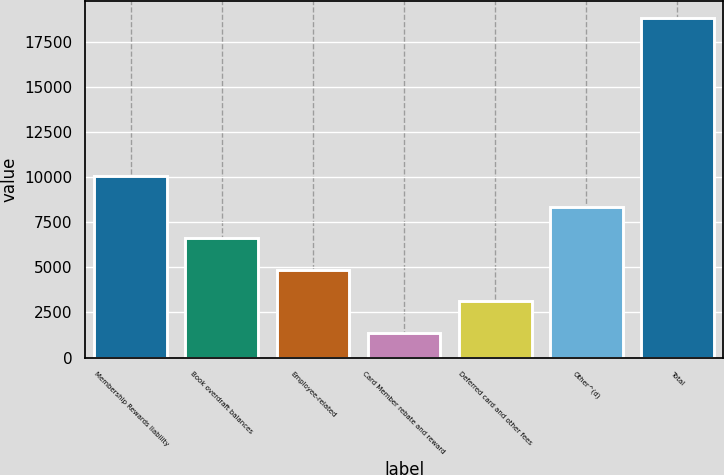Convert chart to OTSL. <chart><loc_0><loc_0><loc_500><loc_500><bar_chart><fcel>Membership Rewards liability<fcel>Book overdraft balances<fcel>Employee-related<fcel>Card Member rebate and reward<fcel>Deferred card and other fees<fcel>Other^(d)<fcel>Total<nl><fcel>10079.5<fcel>6600.5<fcel>4861<fcel>1382<fcel>3121.5<fcel>8340<fcel>18777<nl></chart> 